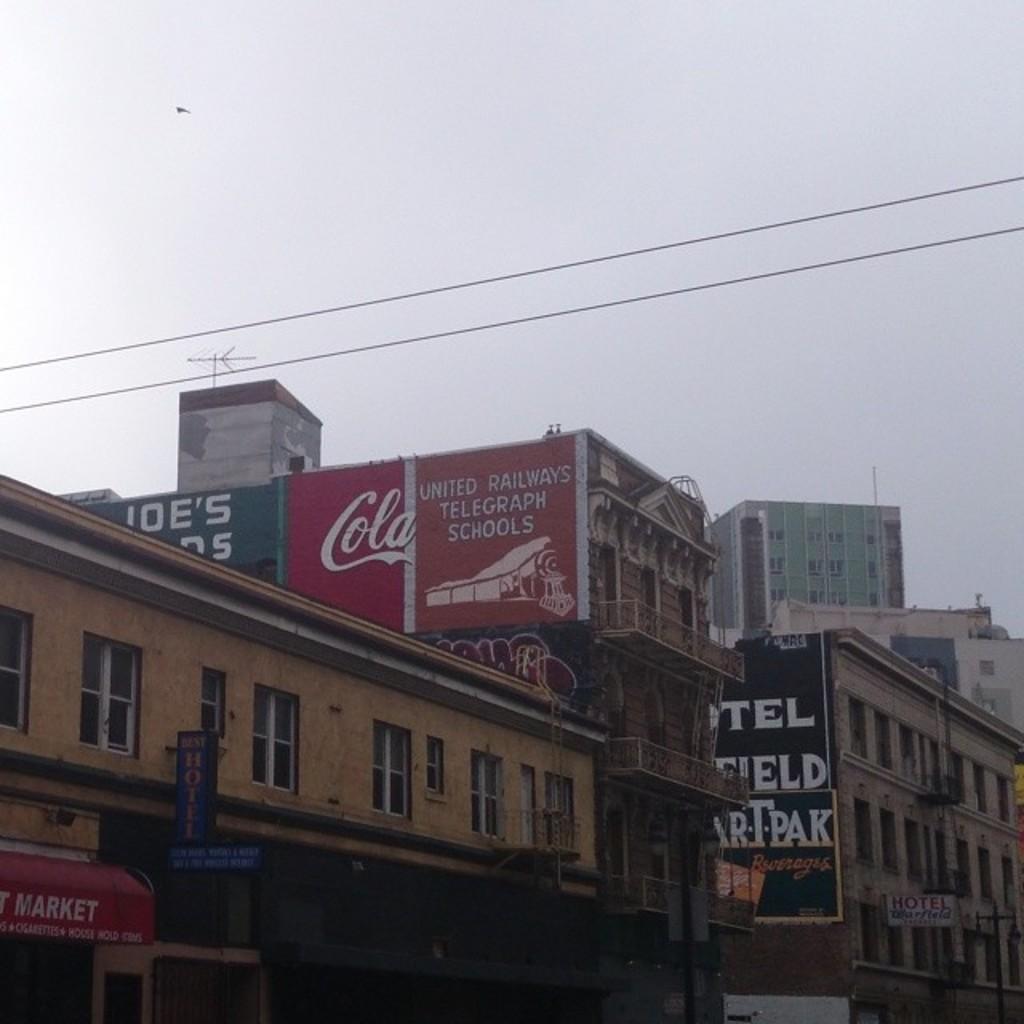What word is in cursive on the red section?
Make the answer very short. Cola. 